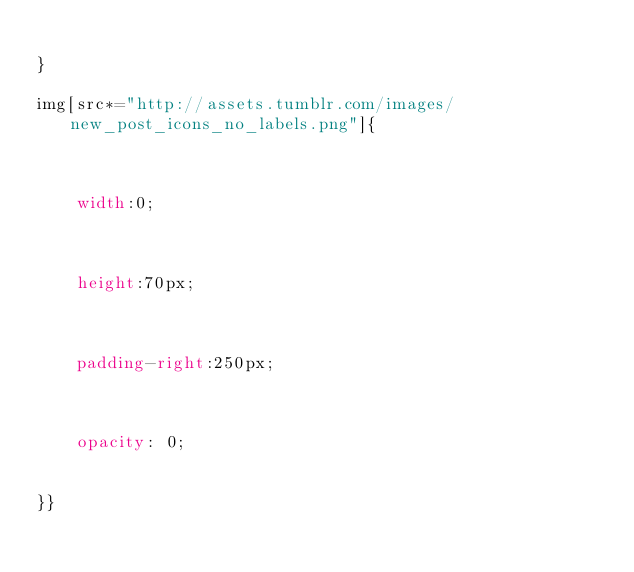<code> <loc_0><loc_0><loc_500><loc_500><_CSS_>
}

img[src*="http://assets.tumblr.com/images/new_post_icons_no_labels.png"]{



    width:0;



    height:70px;



    padding-right:250px;



    opacity: 0;


}}</code> 